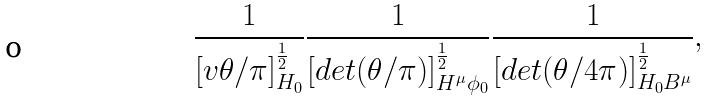Convert formula to latex. <formula><loc_0><loc_0><loc_500><loc_500>\frac { 1 } { [ v \theta / \pi ] _ { H _ { 0 } } ^ { \frac { 1 } { 2 } } } \frac { 1 } { [ d e t ( \theta / \pi ) ] _ { H ^ { \mu } \phi _ { 0 } } ^ { \frac { 1 } { 2 } } } \frac { 1 } { [ d e t ( \theta / 4 \pi ) ] _ { H _ { 0 } B ^ { \mu } } ^ { \frac { 1 } { 2 } } } ,</formula> 